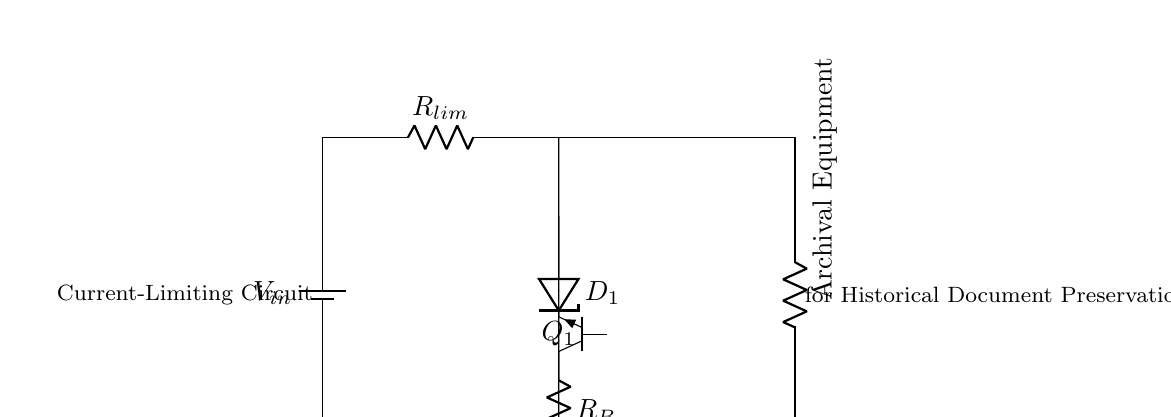What is the input voltage of this circuit? The circuit diagram specifies a power supply labeled V_in, which represents the input voltage. However, the exact numerical value is not given directly in the circuit.
Answer: V_in What component is used for current limiting? The circuit includes a resistor labeled R_lim, which is designated as the current-limiting resistor. This component is responsible for controlling the amount of current flowing through the circuit.
Answer: R_lim How many resistors are in this circuit? By examining the diagram, we can identify two resistors: R_lim (current-limiting resistor) and R_B (base resistor). Therefore, the total number of resistors in the circuit is two.
Answer: 2 What type of transistor is used in this circuit? In the diagram, the transistor is labeled as Q_1 and is indicated to be a Tnpn, which refers to a NPN transistor. This designation signifies the type of bipolar junction transistor utilized in the circuit.
Answer: NPN What is the purpose of the Zener diode? The Zener diode, labeled D_1 in the circuit, is typically used for voltage regulation. In this context, it helps to maintain a specific voltage level across the base of the transistor to prevent damage to the archival equipment from over-voltage conditions.
Answer: Voltage regulation What is the load connected to this circuit? The circuit diagram shows a load labeled as Archival Equipment, which indicates that the entire setup is designed to protect and regulate the current for sensitive equipment that is used for preserving historical documents and newspapers.
Answer: Archival Equipment What does the circuit aim to protect? The primary focus of this circuit, as indicated by the label near the load, is to protect delicate archival equipment from excessive current that could potentially damage the equipment when preserving important historical documents and newspapers.
Answer: Delicate archival equipment 